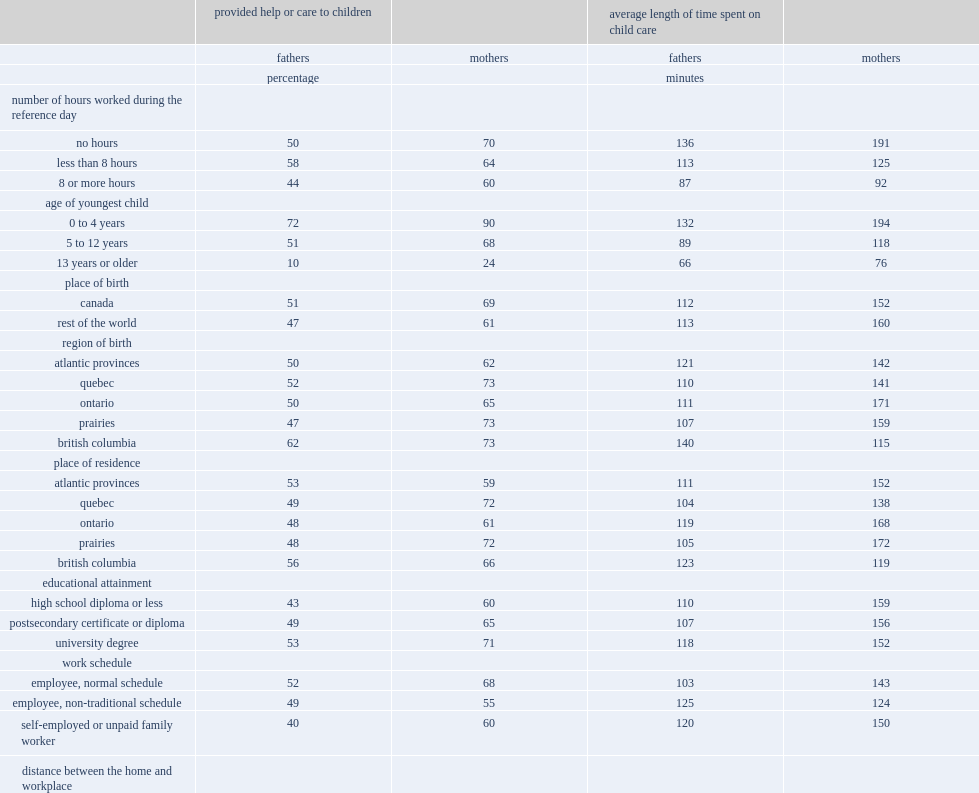What's the percentage of mothers who having participated in 8 hours or more of paid work during the day had provided help or care to their children. 60.0. Who were more likely to provided child care, fathers who had not worked at all during the day or mothers who had worked at a paid job for 8 hours or more during the day? 8 or more hours. 